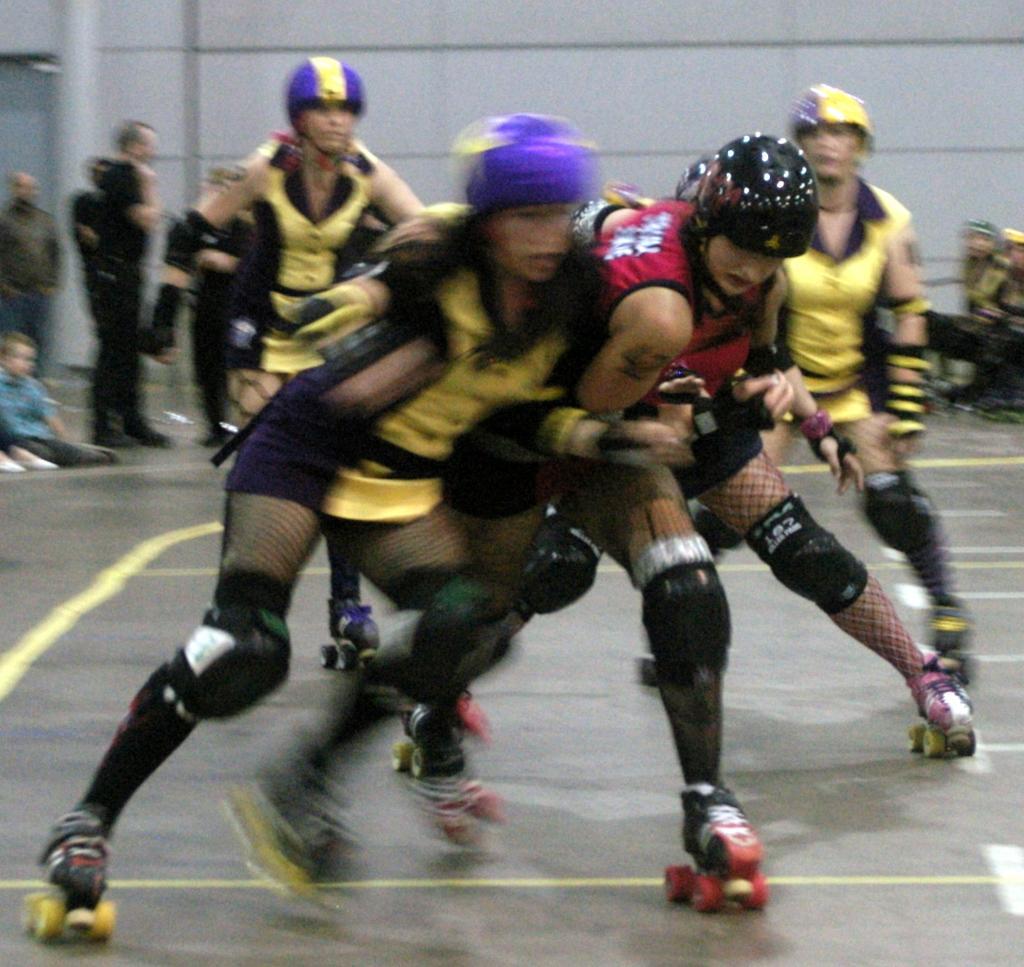Can you describe this image briefly? In this image, we can see few people are playing a game on the floor and wearing skate and helmet. Background there are few people. Few are sitting and standing. Here there is a wall. 